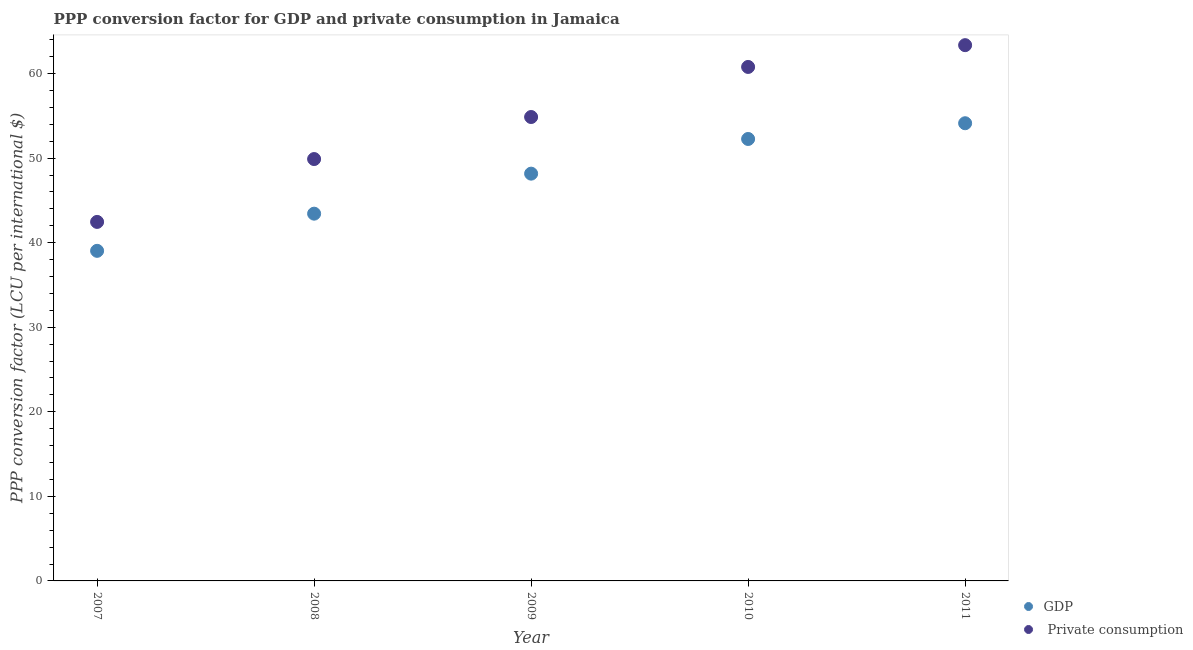Is the number of dotlines equal to the number of legend labels?
Ensure brevity in your answer.  Yes. What is the ppp conversion factor for private consumption in 2008?
Offer a terse response. 49.89. Across all years, what is the maximum ppp conversion factor for gdp?
Your answer should be very brief. 54.12. Across all years, what is the minimum ppp conversion factor for gdp?
Keep it short and to the point. 39.03. In which year was the ppp conversion factor for gdp maximum?
Your answer should be very brief. 2011. What is the total ppp conversion factor for private consumption in the graph?
Your answer should be very brief. 271.33. What is the difference between the ppp conversion factor for private consumption in 2009 and that in 2010?
Your answer should be compact. -5.92. What is the difference between the ppp conversion factor for gdp in 2011 and the ppp conversion factor for private consumption in 2008?
Give a very brief answer. 4.24. What is the average ppp conversion factor for private consumption per year?
Offer a terse response. 54.27. In the year 2007, what is the difference between the ppp conversion factor for gdp and ppp conversion factor for private consumption?
Your answer should be compact. -3.42. What is the ratio of the ppp conversion factor for private consumption in 2007 to that in 2008?
Give a very brief answer. 0.85. Is the ppp conversion factor for gdp in 2008 less than that in 2010?
Keep it short and to the point. Yes. What is the difference between the highest and the second highest ppp conversion factor for gdp?
Your answer should be very brief. 1.86. What is the difference between the highest and the lowest ppp conversion factor for private consumption?
Give a very brief answer. 20.9. Is the sum of the ppp conversion factor for private consumption in 2009 and 2011 greater than the maximum ppp conversion factor for gdp across all years?
Provide a short and direct response. Yes. Is the ppp conversion factor for private consumption strictly less than the ppp conversion factor for gdp over the years?
Make the answer very short. No. How many years are there in the graph?
Provide a succinct answer. 5. Does the graph contain any zero values?
Your answer should be very brief. No. Where does the legend appear in the graph?
Provide a short and direct response. Bottom right. How are the legend labels stacked?
Offer a terse response. Vertical. What is the title of the graph?
Provide a succinct answer. PPP conversion factor for GDP and private consumption in Jamaica. What is the label or title of the X-axis?
Provide a short and direct response. Year. What is the label or title of the Y-axis?
Your answer should be compact. PPP conversion factor (LCU per international $). What is the PPP conversion factor (LCU per international $) in GDP in 2007?
Provide a succinct answer. 39.03. What is the PPP conversion factor (LCU per international $) in  Private consumption in 2007?
Keep it short and to the point. 42.45. What is the PPP conversion factor (LCU per international $) in GDP in 2008?
Make the answer very short. 43.43. What is the PPP conversion factor (LCU per international $) of  Private consumption in 2008?
Give a very brief answer. 49.89. What is the PPP conversion factor (LCU per international $) of GDP in 2009?
Provide a succinct answer. 48.16. What is the PPP conversion factor (LCU per international $) in  Private consumption in 2009?
Your answer should be compact. 54.86. What is the PPP conversion factor (LCU per international $) of GDP in 2010?
Provide a short and direct response. 52.26. What is the PPP conversion factor (LCU per international $) in  Private consumption in 2010?
Give a very brief answer. 60.78. What is the PPP conversion factor (LCU per international $) of GDP in 2011?
Your answer should be compact. 54.12. What is the PPP conversion factor (LCU per international $) of  Private consumption in 2011?
Keep it short and to the point. 63.35. Across all years, what is the maximum PPP conversion factor (LCU per international $) of GDP?
Offer a terse response. 54.12. Across all years, what is the maximum PPP conversion factor (LCU per international $) of  Private consumption?
Provide a short and direct response. 63.35. Across all years, what is the minimum PPP conversion factor (LCU per international $) in GDP?
Your answer should be compact. 39.03. Across all years, what is the minimum PPP conversion factor (LCU per international $) of  Private consumption?
Provide a succinct answer. 42.45. What is the total PPP conversion factor (LCU per international $) in GDP in the graph?
Offer a terse response. 237. What is the total PPP conversion factor (LCU per international $) of  Private consumption in the graph?
Provide a short and direct response. 271.33. What is the difference between the PPP conversion factor (LCU per international $) of GDP in 2007 and that in 2008?
Provide a succinct answer. -4.4. What is the difference between the PPP conversion factor (LCU per international $) of  Private consumption in 2007 and that in 2008?
Provide a succinct answer. -7.43. What is the difference between the PPP conversion factor (LCU per international $) of GDP in 2007 and that in 2009?
Ensure brevity in your answer.  -9.13. What is the difference between the PPP conversion factor (LCU per international $) of  Private consumption in 2007 and that in 2009?
Your answer should be very brief. -12.4. What is the difference between the PPP conversion factor (LCU per international $) of GDP in 2007 and that in 2010?
Offer a very short reply. -13.23. What is the difference between the PPP conversion factor (LCU per international $) in  Private consumption in 2007 and that in 2010?
Ensure brevity in your answer.  -18.32. What is the difference between the PPP conversion factor (LCU per international $) in GDP in 2007 and that in 2011?
Offer a terse response. -15.09. What is the difference between the PPP conversion factor (LCU per international $) in  Private consumption in 2007 and that in 2011?
Your response must be concise. -20.9. What is the difference between the PPP conversion factor (LCU per international $) in GDP in 2008 and that in 2009?
Provide a succinct answer. -4.73. What is the difference between the PPP conversion factor (LCU per international $) in  Private consumption in 2008 and that in 2009?
Provide a short and direct response. -4.97. What is the difference between the PPP conversion factor (LCU per international $) of GDP in 2008 and that in 2010?
Keep it short and to the point. -8.83. What is the difference between the PPP conversion factor (LCU per international $) in  Private consumption in 2008 and that in 2010?
Offer a terse response. -10.89. What is the difference between the PPP conversion factor (LCU per international $) in GDP in 2008 and that in 2011?
Your answer should be very brief. -10.69. What is the difference between the PPP conversion factor (LCU per international $) in  Private consumption in 2008 and that in 2011?
Make the answer very short. -13.47. What is the difference between the PPP conversion factor (LCU per international $) of GDP in 2009 and that in 2010?
Keep it short and to the point. -4.1. What is the difference between the PPP conversion factor (LCU per international $) in  Private consumption in 2009 and that in 2010?
Keep it short and to the point. -5.92. What is the difference between the PPP conversion factor (LCU per international $) in GDP in 2009 and that in 2011?
Keep it short and to the point. -5.96. What is the difference between the PPP conversion factor (LCU per international $) of  Private consumption in 2009 and that in 2011?
Make the answer very short. -8.5. What is the difference between the PPP conversion factor (LCU per international $) in GDP in 2010 and that in 2011?
Ensure brevity in your answer.  -1.86. What is the difference between the PPP conversion factor (LCU per international $) in  Private consumption in 2010 and that in 2011?
Offer a terse response. -2.58. What is the difference between the PPP conversion factor (LCU per international $) of GDP in 2007 and the PPP conversion factor (LCU per international $) of  Private consumption in 2008?
Offer a very short reply. -10.85. What is the difference between the PPP conversion factor (LCU per international $) in GDP in 2007 and the PPP conversion factor (LCU per international $) in  Private consumption in 2009?
Ensure brevity in your answer.  -15.83. What is the difference between the PPP conversion factor (LCU per international $) in GDP in 2007 and the PPP conversion factor (LCU per international $) in  Private consumption in 2010?
Your answer should be very brief. -21.75. What is the difference between the PPP conversion factor (LCU per international $) in GDP in 2007 and the PPP conversion factor (LCU per international $) in  Private consumption in 2011?
Offer a very short reply. -24.32. What is the difference between the PPP conversion factor (LCU per international $) of GDP in 2008 and the PPP conversion factor (LCU per international $) of  Private consumption in 2009?
Provide a succinct answer. -11.43. What is the difference between the PPP conversion factor (LCU per international $) of GDP in 2008 and the PPP conversion factor (LCU per international $) of  Private consumption in 2010?
Offer a terse response. -17.35. What is the difference between the PPP conversion factor (LCU per international $) in GDP in 2008 and the PPP conversion factor (LCU per international $) in  Private consumption in 2011?
Make the answer very short. -19.93. What is the difference between the PPP conversion factor (LCU per international $) of GDP in 2009 and the PPP conversion factor (LCU per international $) of  Private consumption in 2010?
Make the answer very short. -12.62. What is the difference between the PPP conversion factor (LCU per international $) of GDP in 2009 and the PPP conversion factor (LCU per international $) of  Private consumption in 2011?
Give a very brief answer. -15.19. What is the difference between the PPP conversion factor (LCU per international $) in GDP in 2010 and the PPP conversion factor (LCU per international $) in  Private consumption in 2011?
Offer a very short reply. -11.09. What is the average PPP conversion factor (LCU per international $) of GDP per year?
Make the answer very short. 47.4. What is the average PPP conversion factor (LCU per international $) in  Private consumption per year?
Ensure brevity in your answer.  54.27. In the year 2007, what is the difference between the PPP conversion factor (LCU per international $) in GDP and PPP conversion factor (LCU per international $) in  Private consumption?
Your answer should be very brief. -3.42. In the year 2008, what is the difference between the PPP conversion factor (LCU per international $) of GDP and PPP conversion factor (LCU per international $) of  Private consumption?
Keep it short and to the point. -6.46. In the year 2009, what is the difference between the PPP conversion factor (LCU per international $) in GDP and PPP conversion factor (LCU per international $) in  Private consumption?
Keep it short and to the point. -6.7. In the year 2010, what is the difference between the PPP conversion factor (LCU per international $) of GDP and PPP conversion factor (LCU per international $) of  Private consumption?
Provide a succinct answer. -8.52. In the year 2011, what is the difference between the PPP conversion factor (LCU per international $) of GDP and PPP conversion factor (LCU per international $) of  Private consumption?
Provide a succinct answer. -9.23. What is the ratio of the PPP conversion factor (LCU per international $) in GDP in 2007 to that in 2008?
Make the answer very short. 0.9. What is the ratio of the PPP conversion factor (LCU per international $) in  Private consumption in 2007 to that in 2008?
Make the answer very short. 0.85. What is the ratio of the PPP conversion factor (LCU per international $) in GDP in 2007 to that in 2009?
Provide a succinct answer. 0.81. What is the ratio of the PPP conversion factor (LCU per international $) of  Private consumption in 2007 to that in 2009?
Keep it short and to the point. 0.77. What is the ratio of the PPP conversion factor (LCU per international $) in GDP in 2007 to that in 2010?
Give a very brief answer. 0.75. What is the ratio of the PPP conversion factor (LCU per international $) of  Private consumption in 2007 to that in 2010?
Provide a short and direct response. 0.7. What is the ratio of the PPP conversion factor (LCU per international $) in GDP in 2007 to that in 2011?
Offer a very short reply. 0.72. What is the ratio of the PPP conversion factor (LCU per international $) of  Private consumption in 2007 to that in 2011?
Offer a very short reply. 0.67. What is the ratio of the PPP conversion factor (LCU per international $) of GDP in 2008 to that in 2009?
Your answer should be compact. 0.9. What is the ratio of the PPP conversion factor (LCU per international $) of  Private consumption in 2008 to that in 2009?
Your answer should be very brief. 0.91. What is the ratio of the PPP conversion factor (LCU per international $) of GDP in 2008 to that in 2010?
Offer a terse response. 0.83. What is the ratio of the PPP conversion factor (LCU per international $) in  Private consumption in 2008 to that in 2010?
Your answer should be very brief. 0.82. What is the ratio of the PPP conversion factor (LCU per international $) of GDP in 2008 to that in 2011?
Offer a very short reply. 0.8. What is the ratio of the PPP conversion factor (LCU per international $) of  Private consumption in 2008 to that in 2011?
Offer a terse response. 0.79. What is the ratio of the PPP conversion factor (LCU per international $) in GDP in 2009 to that in 2010?
Your answer should be compact. 0.92. What is the ratio of the PPP conversion factor (LCU per international $) in  Private consumption in 2009 to that in 2010?
Your answer should be very brief. 0.9. What is the ratio of the PPP conversion factor (LCU per international $) in GDP in 2009 to that in 2011?
Your answer should be compact. 0.89. What is the ratio of the PPP conversion factor (LCU per international $) of  Private consumption in 2009 to that in 2011?
Provide a succinct answer. 0.87. What is the ratio of the PPP conversion factor (LCU per international $) of GDP in 2010 to that in 2011?
Keep it short and to the point. 0.97. What is the ratio of the PPP conversion factor (LCU per international $) of  Private consumption in 2010 to that in 2011?
Provide a short and direct response. 0.96. What is the difference between the highest and the second highest PPP conversion factor (LCU per international $) of GDP?
Offer a terse response. 1.86. What is the difference between the highest and the second highest PPP conversion factor (LCU per international $) of  Private consumption?
Provide a succinct answer. 2.58. What is the difference between the highest and the lowest PPP conversion factor (LCU per international $) of GDP?
Provide a short and direct response. 15.09. What is the difference between the highest and the lowest PPP conversion factor (LCU per international $) of  Private consumption?
Offer a terse response. 20.9. 